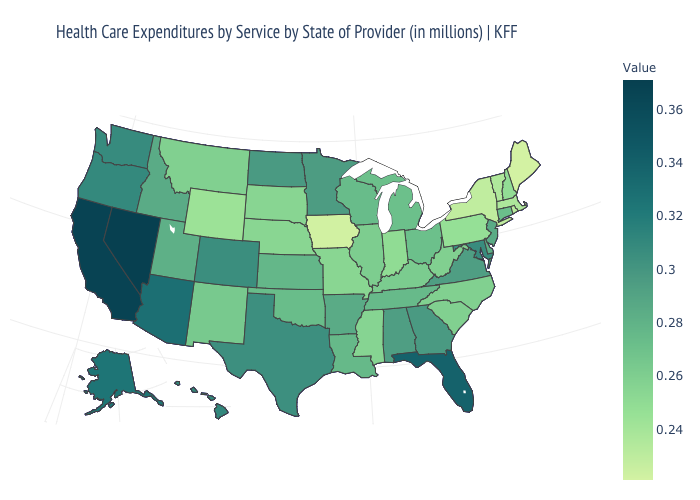Does Nevada have the highest value in the West?
Quick response, please. Yes. Which states have the highest value in the USA?
Keep it brief. Nevada. Does Arkansas have the highest value in the South?
Be succinct. No. Which states have the highest value in the USA?
Concise answer only. Nevada. Among the states that border Arkansas , which have the lowest value?
Short answer required. Missouri. Which states have the lowest value in the USA?
Keep it brief. Maine. 